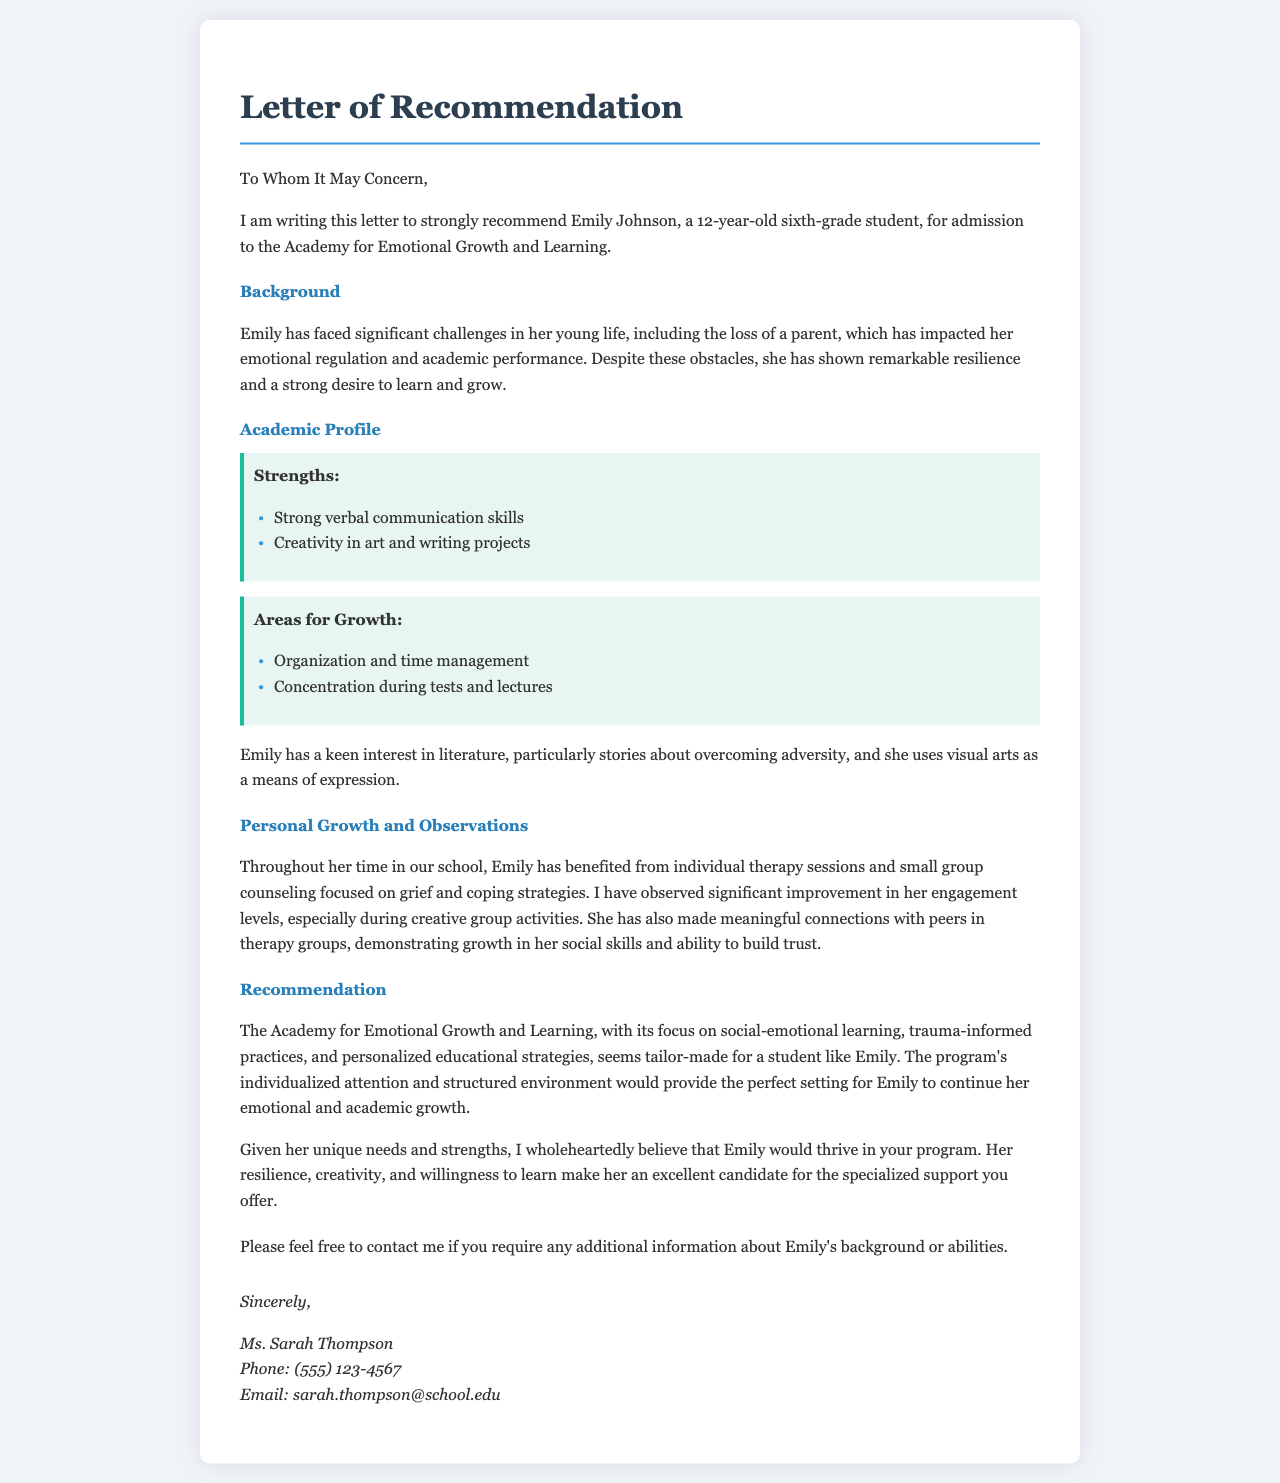What is the student's name? The document begins by mentioning Emily Johnson, who is the subject of the letter.
Answer: Emily Johnson What is Emily's age and grade? It states that Emily is a 12-year-old sixth-grade student.
Answer: 12 years old, sixth grade What significant challenge has Emily faced? The letter describes the loss of a parent as a significant challenge in Emily's life.
Answer: Loss of a parent What are Emily's strengths mentioned in the letter? The document lists strong verbal communication skills and creativity in art and writing as her strengths.
Answer: Strong verbal communication skills, creativity in art and writing What does the acronym "SEL" stand for in the context of the Academy? The letter discusses the Academy's focus on social-emotional learning, which is often abbreviated as SEL.
Answer: Social-emotional learning How has Emily's engagement improved? The letter notes that her engagement levels have significantly improved, especially in creative group activities.
Answer: Significant improvement What does the recommending teacher invite the recipient to do? The letter closes with an invitation to contact the teacher for additional information.
Answer: Contact for additional information What is the name of the recommending teacher? The letter provides the name of the teacher who is recommending Emily.
Answer: Ms. Sarah Thompson What is the primary focus of the Academy for Emotional Growth and Learning according to the letter? The letter emphasizes the Academy's focus on social-emotional learning and trauma-informed practices.
Answer: Social-emotional learning and trauma-informed practices 